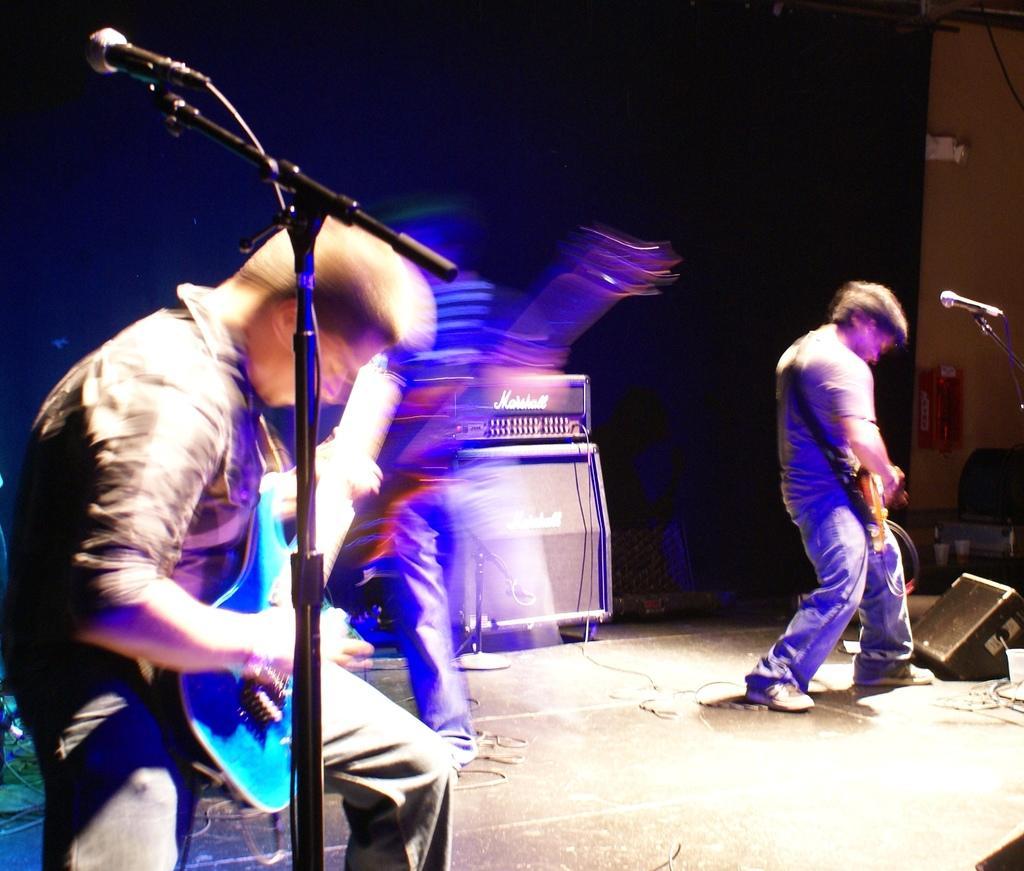How would you summarize this image in a sentence or two? In this image I can see few people and I can see they all are holding guitars. I can also see few mics, few speakers and in the background I can see a black colour thing. 